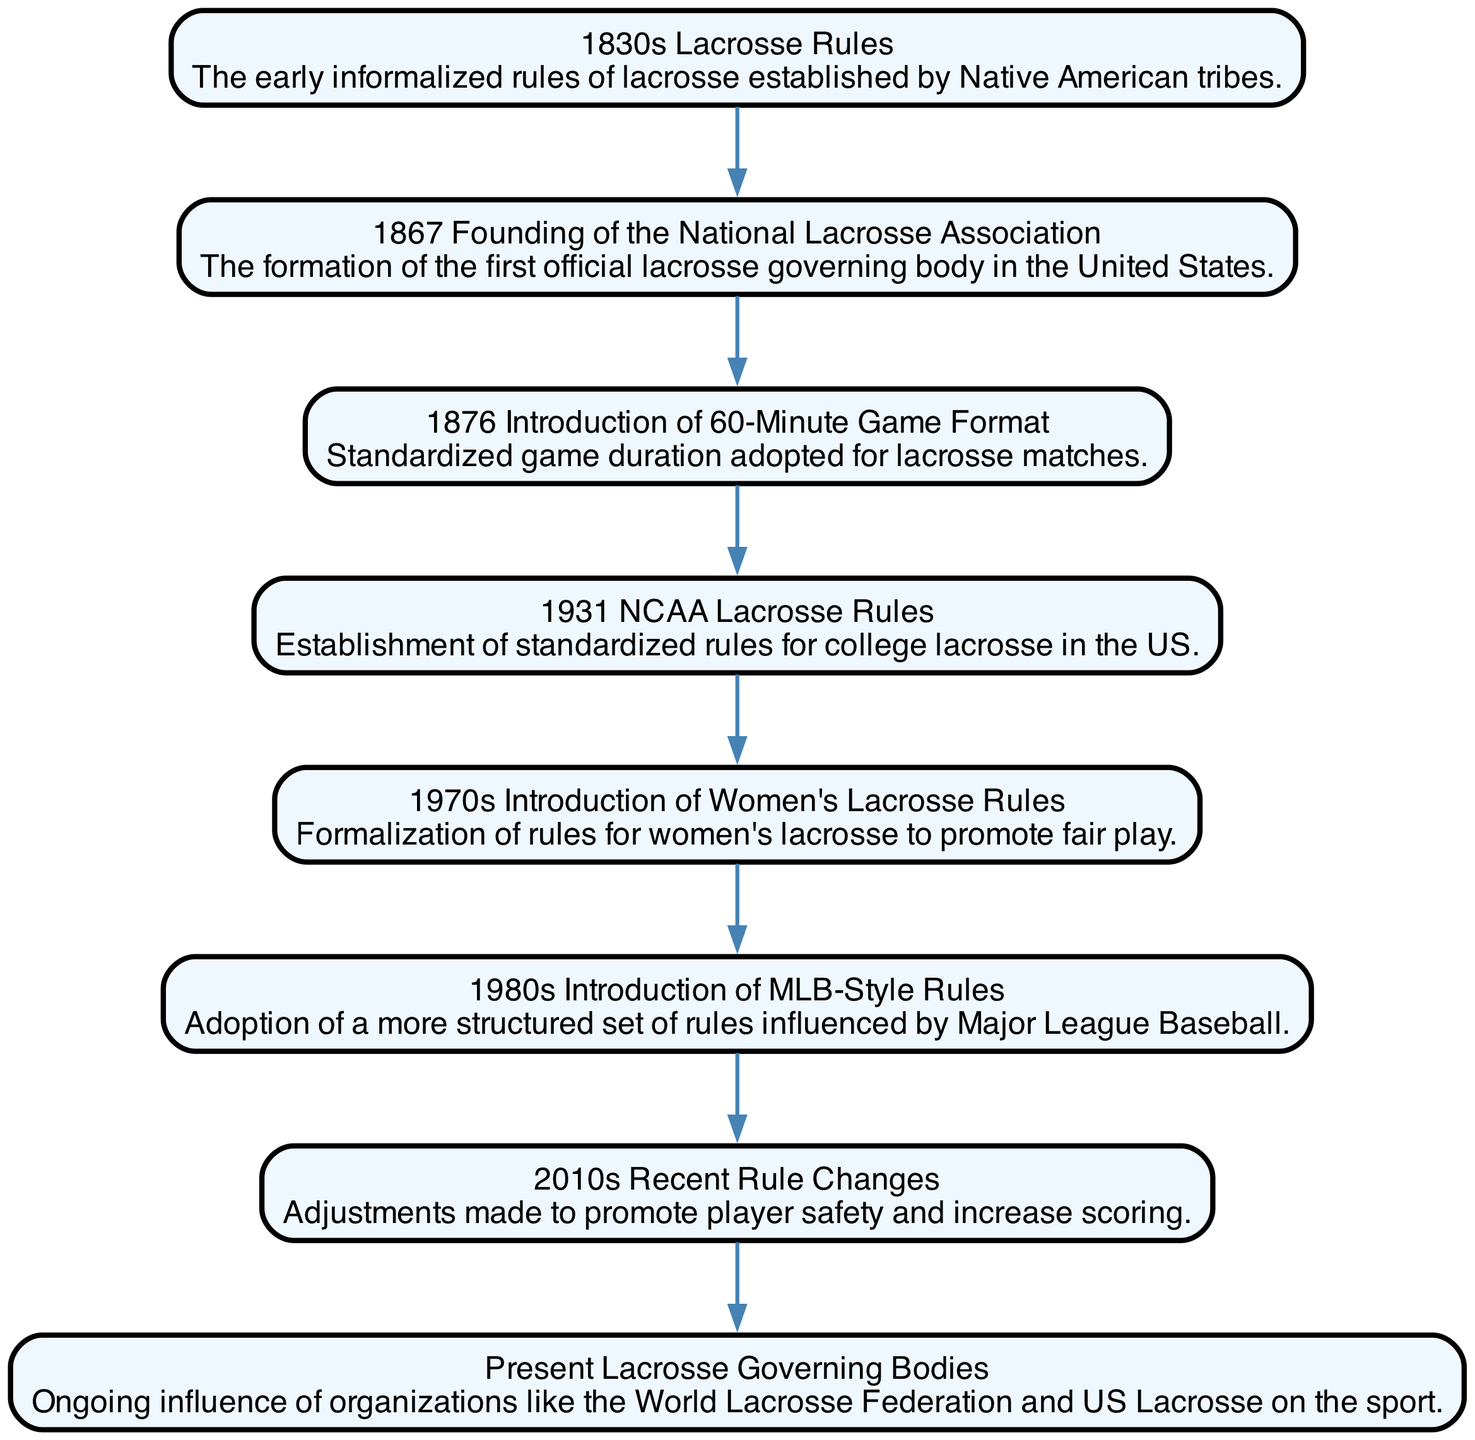What are the earliest lacrosse rules depicted in the diagram? The diagram shows "1830s Lacrosse Rules" as the earliest rules established by Native American tribes. This node is at the top of the directed graph, indicating its chronological position.
Answer: 1830s Lacrosse Rules How many nodes are present in the diagram? By counting the elements listed in the data, there are a total of eight distinct nodes that represent different milestones in the evolution of lacrosse rules.
Answer: 8 What is the last event related to lacrosse rules in the timeline? Following the chronological flow of the edges in the diagram, the last event connected through the edges is the "Present Lacrosse Governing Bodies," which indicates ongoing influence on the sport.
Answer: Present Lacrosse Governing Bodies What was introduced in 1970s concerning lacrosse? The diagram specifies "1970s Introduction of Women's Lacrosse Rules," highlighting the formalization of rules specifically for women's lacrosse to promote fair play.
Answer: 1970s Introduction of Women's Lacrosse Rules Which event directly follows the founding of the National Lacrosse Association? The directed graph indicates that "1876 Introduction of 60-Minute Game Format" directly follows the "1867 Founding of the National Lacrosse Association," showing the progression of rule formalization in lacrosse.
Answer: 1876 Introduction of 60-Minute Game Format What influence did MLB-style rules have on lacrosse? The "1980s Introduction of MLB-Style Rules" node represents the adoption of a more structured set of rules influenced by Major League Baseball, indicating a shift towards more formal regulations in the sport.
Answer: 1980s Introduction of MLB-Style Rules Which two nodes show the evolution of women's lacrosse rules in the graph? By evaluating the nodes, "1970s Introduction of Women's Lacrosse Rules" and "Present Lacrosse Governing Bodies" indicate the progression of women's lacrosse rules and the ongoing influence of governing bodies over those regulations.
Answer: 1970s Introduction of Women's Lacrosse Rules, Present Lacrosse Governing Bodies How do the 2010s rule changes relate to player safety? The "2010s Recent Rule Changes" node points out that these adjustments were made to promote player safety and increase scoring, reflecting a response to evolving concerns regarding player welfare in the sport.
Answer: 2010s Recent Rule Changes 